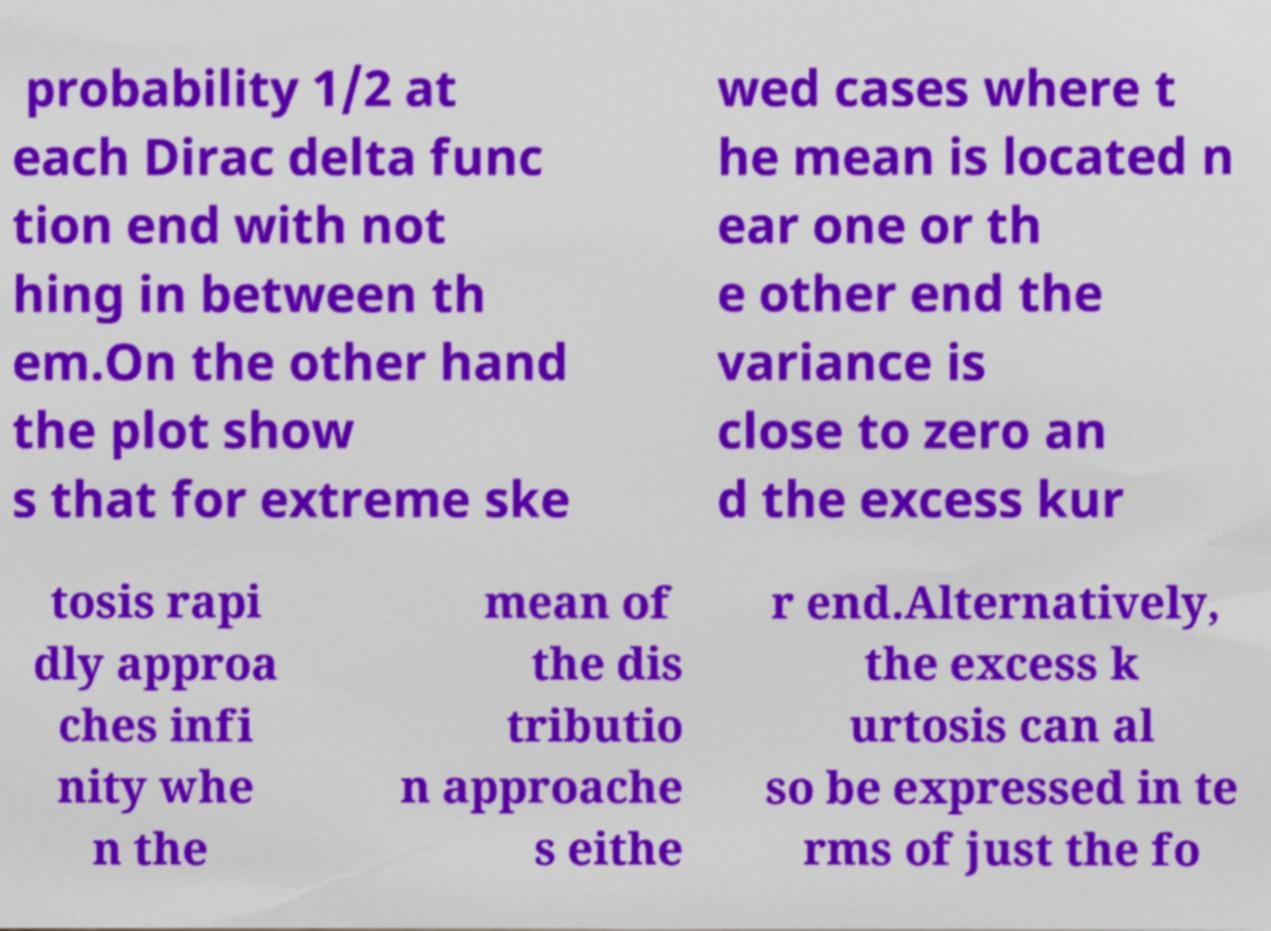Can you read and provide the text displayed in the image?This photo seems to have some interesting text. Can you extract and type it out for me? probability 1/2 at each Dirac delta func tion end with not hing in between th em.On the other hand the plot show s that for extreme ske wed cases where t he mean is located n ear one or th e other end the variance is close to zero an d the excess kur tosis rapi dly approa ches infi nity whe n the mean of the dis tributio n approache s eithe r end.Alternatively, the excess k urtosis can al so be expressed in te rms of just the fo 